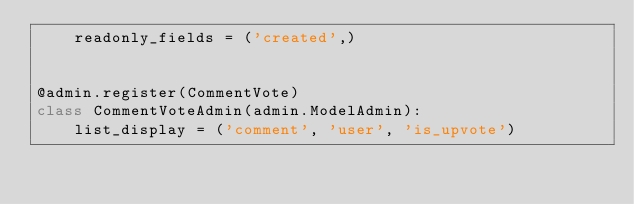<code> <loc_0><loc_0><loc_500><loc_500><_Python_>    readonly_fields = ('created',)


@admin.register(CommentVote)
class CommentVoteAdmin(admin.ModelAdmin):
    list_display = ('comment', 'user', 'is_upvote')
</code> 